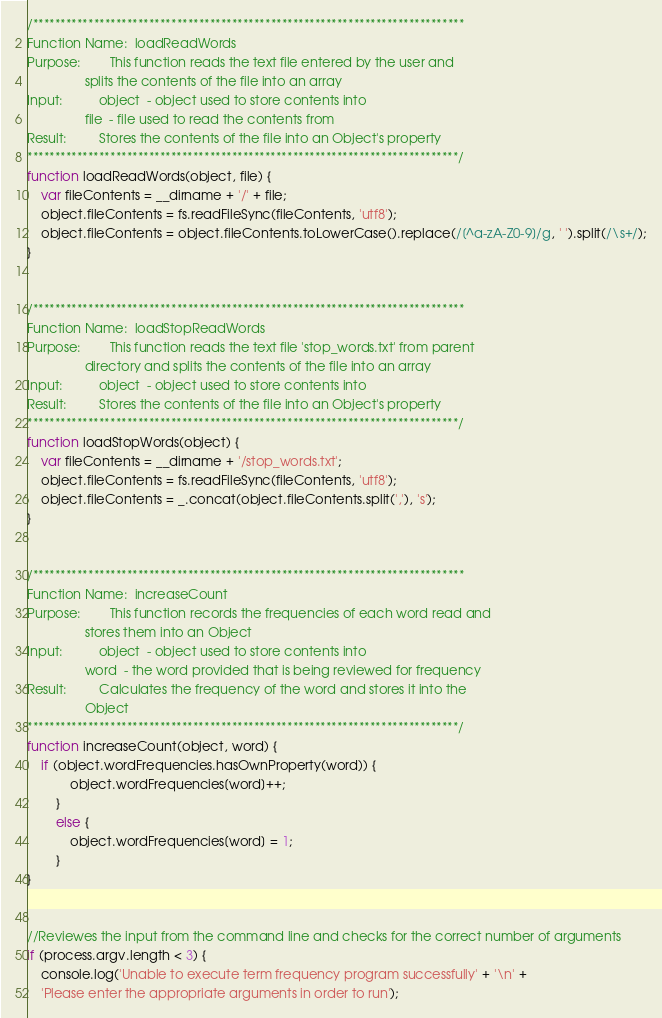Convert code to text. <code><loc_0><loc_0><loc_500><loc_500><_JavaScript_>

/******************************************************************************
Function Name:  loadReadWords
Purpose:        This function reads the text file entered by the user and
                splits the contents of the file into an array
Input:          object  - object used to store contents into
                file  - file used to read the contents from
Result:         Stores the contents of the file into an Object's property
******************************************************************************/
function loadReadWords(object, file) {
    var fileContents = __dirname + '/' + file;
    object.fileContents = fs.readFileSync(fileContents, 'utf8');
    object.fileContents = object.fileContents.toLowerCase().replace(/[^a-zA-Z0-9]/g, ' ').split(/\s+/);
}


/******************************************************************************
Function Name:  loadStopReadWords
Purpose:        This function reads the text file 'stop_words.txt' from parent
                directory and splits the contents of the file into an array
Input:          object  - object used to store contents into
Result:         Stores the contents of the file into an Object's property
******************************************************************************/
function loadStopWords(object) {
    var fileContents = __dirname + '/stop_words.txt';
    object.fileContents = fs.readFileSync(fileContents, 'utf8');
    object.fileContents = _.concat(object.fileContents.split(','), 's');
}


/******************************************************************************
Function Name:  increaseCount
Purpose:        This function records the frequencies of each word read and
                stores them into an Object
Input:          object  - object used to store contents into
                word  - the word provided that is being reviewed for frequency
Result:         Calculates the frequency of the word and stores it into the
                Object
******************************************************************************/
function increaseCount(object, word) {
    if (object.wordFrequencies.hasOwnProperty(word)) {
            object.wordFrequencies[word]++;
        }
        else {
            object.wordFrequencies[word] = 1;
        }
}


//Reviewes the input from the command line and checks for the correct number of arguments
if (process.argv.length < 3) {
    console.log('Unable to execute term frequency program successfully' + '\n' +
    'Please enter the appropriate arguments in order to run');</code> 